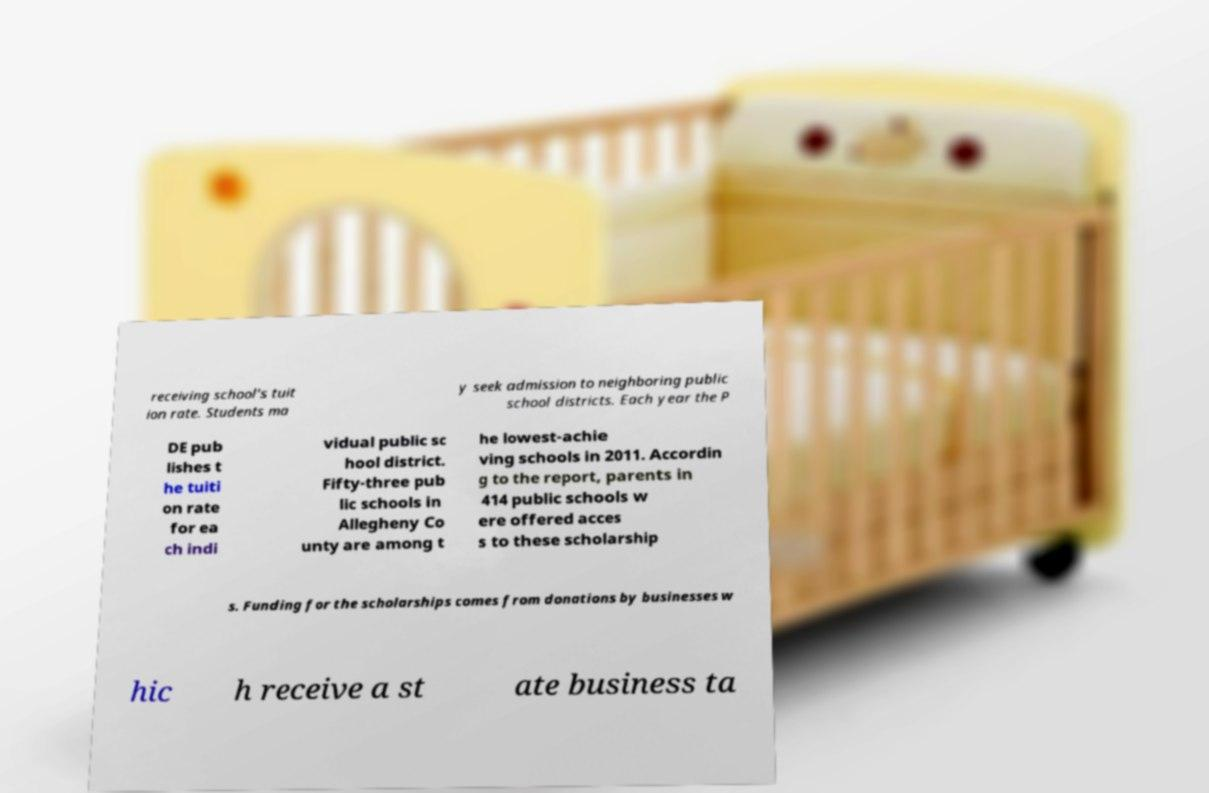I need the written content from this picture converted into text. Can you do that? receiving school's tuit ion rate. Students ma y seek admission to neighboring public school districts. Each year the P DE pub lishes t he tuiti on rate for ea ch indi vidual public sc hool district. Fifty-three pub lic schools in Allegheny Co unty are among t he lowest-achie ving schools in 2011. Accordin g to the report, parents in 414 public schools w ere offered acces s to these scholarship s. Funding for the scholarships comes from donations by businesses w hic h receive a st ate business ta 